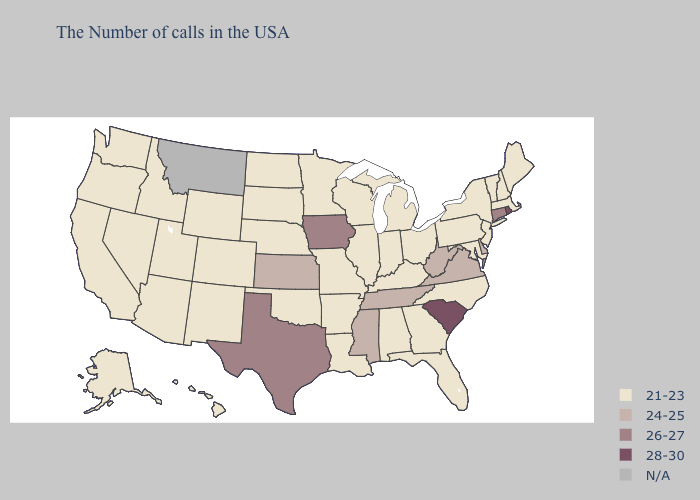Name the states that have a value in the range 21-23?
Answer briefly. Maine, Massachusetts, New Hampshire, Vermont, New York, New Jersey, Maryland, Pennsylvania, North Carolina, Ohio, Florida, Georgia, Michigan, Kentucky, Indiana, Alabama, Wisconsin, Illinois, Louisiana, Missouri, Arkansas, Minnesota, Nebraska, Oklahoma, South Dakota, North Dakota, Wyoming, Colorado, New Mexico, Utah, Arizona, Idaho, Nevada, California, Washington, Oregon, Alaska, Hawaii. Does Iowa have the lowest value in the MidWest?
Short answer required. No. Which states hav the highest value in the MidWest?
Give a very brief answer. Iowa. Which states have the highest value in the USA?
Concise answer only. Rhode Island, South Carolina. Among the states that border Alabama , which have the highest value?
Write a very short answer. Tennessee, Mississippi. Which states have the highest value in the USA?
Answer briefly. Rhode Island, South Carolina. What is the value of Delaware?
Keep it brief. 24-25. Name the states that have a value in the range 24-25?
Keep it brief. Delaware, Virginia, West Virginia, Tennessee, Mississippi, Kansas. Which states have the lowest value in the USA?
Give a very brief answer. Maine, Massachusetts, New Hampshire, Vermont, New York, New Jersey, Maryland, Pennsylvania, North Carolina, Ohio, Florida, Georgia, Michigan, Kentucky, Indiana, Alabama, Wisconsin, Illinois, Louisiana, Missouri, Arkansas, Minnesota, Nebraska, Oklahoma, South Dakota, North Dakota, Wyoming, Colorado, New Mexico, Utah, Arizona, Idaho, Nevada, California, Washington, Oregon, Alaska, Hawaii. Does Connecticut have the lowest value in the Northeast?
Give a very brief answer. No. Among the states that border West Virginia , which have the lowest value?
Answer briefly. Maryland, Pennsylvania, Ohio, Kentucky. What is the value of Missouri?
Concise answer only. 21-23. 